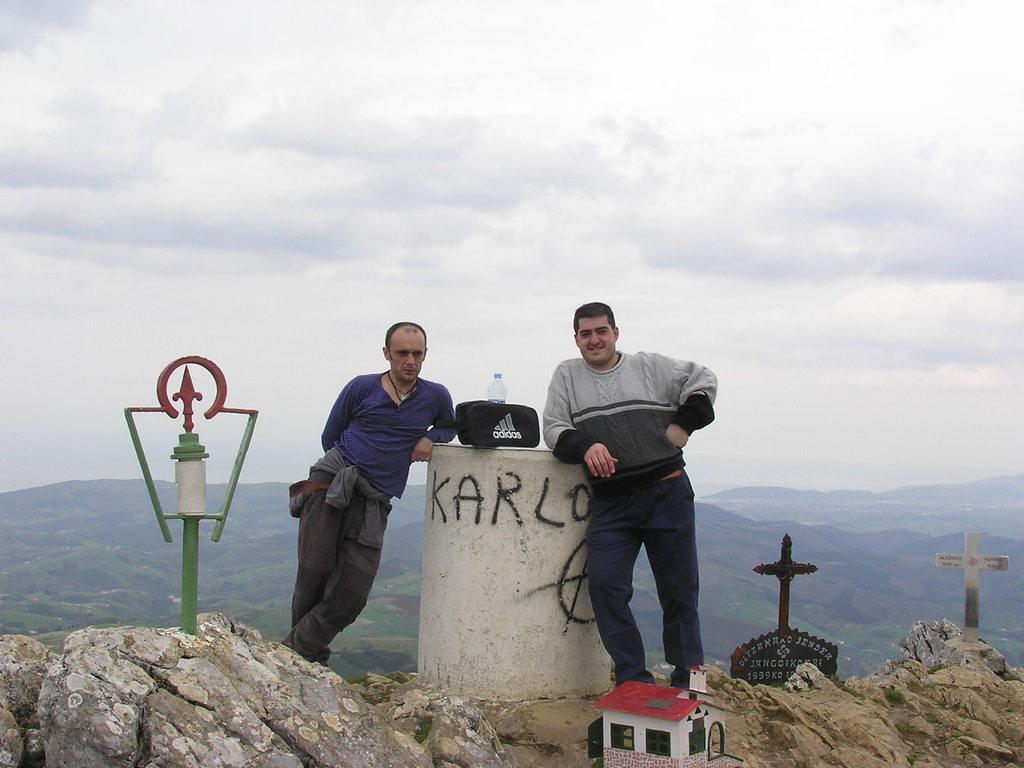How would you summarize this image in a sentence or two? As we can see in the image there is a toy house, rocks, two people standing in the front, hills, trees, sky and clouds. 